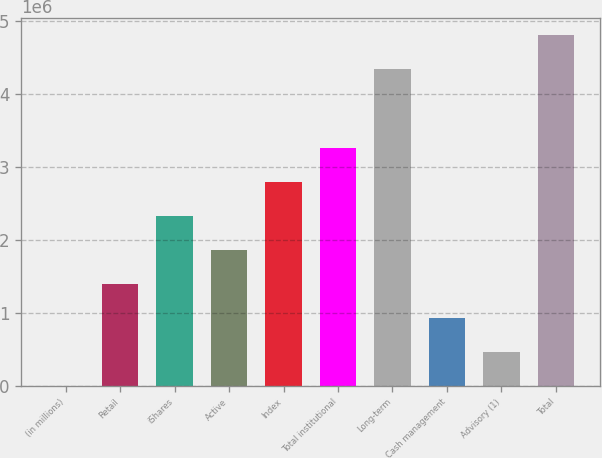Convert chart. <chart><loc_0><loc_0><loc_500><loc_500><bar_chart><fcel>(in millions)<fcel>Retail<fcel>iShares<fcel>Active<fcel>Index<fcel>Total institutional<fcel>Long-term<fcel>Cash management<fcel>Advisory (1)<fcel>Total<nl><fcel>2014<fcel>1.39698e+06<fcel>2.32695e+06<fcel>1.86197e+06<fcel>2.79194e+06<fcel>3.25693e+06<fcel>4.33384e+06<fcel>931990<fcel>467002<fcel>4.79883e+06<nl></chart> 